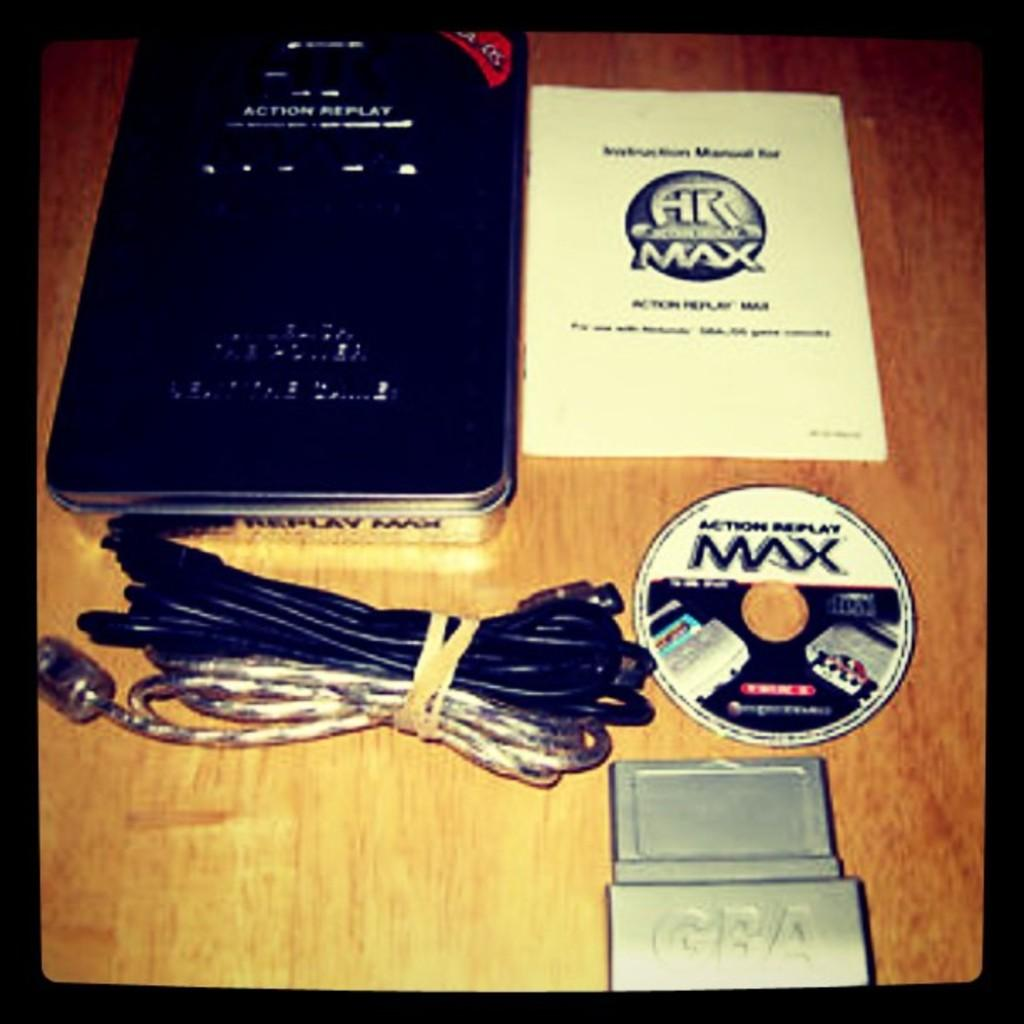What is the main piece of furniture in the image? There is a table in the image. What is placed on the table? The table has a book on it, a compact disc, wires, and other objects. What can be read on the book? The book has text on it. What type of object is typically used for storing and playing music that is present on the table? There is a compact disc on the table, which is a type of object used for storing and playing music. Can you describe the worm crawling on the book in the image? There is no worm present in the image; the book has text on it. What scene from a movie can be seen playing on the table in the image? There is no movie scene present in the image; it features a table with various objects on it. 